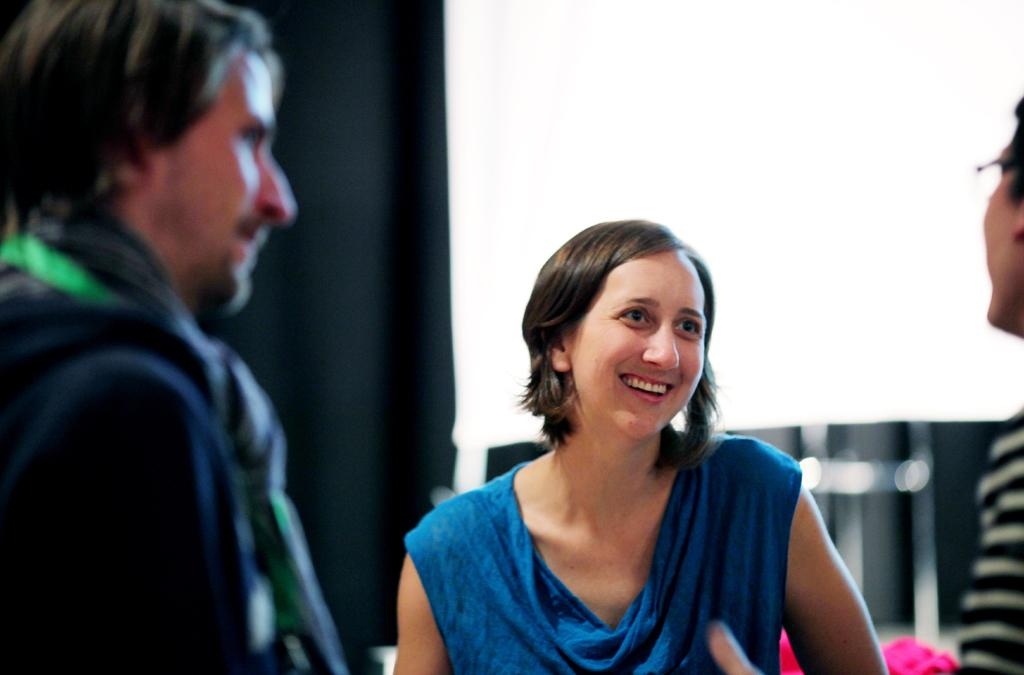What is located in the foreground of the image? There are people in the foreground of the image. What can be seen in the background of the image? There is a black color curtain in the background of the image. What type of advertisement can be seen on the boat in the image? There is no boat present in the image, so there cannot be an advertisement on it. 